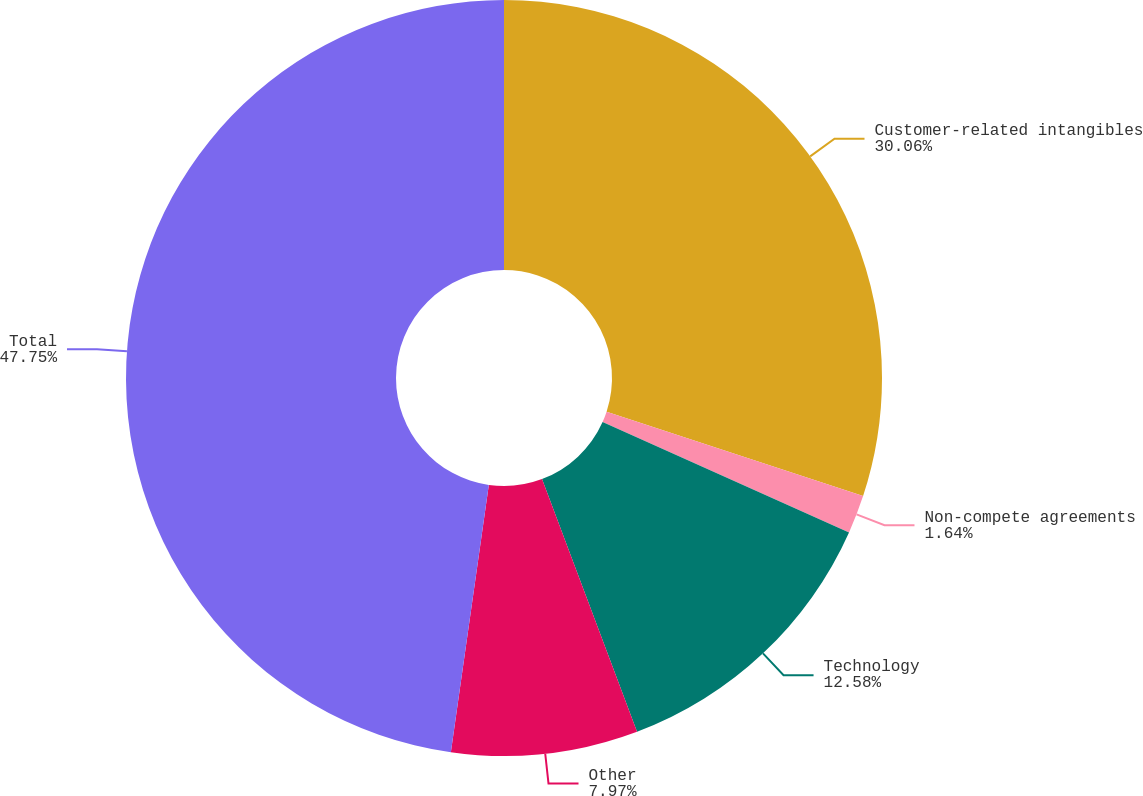Convert chart. <chart><loc_0><loc_0><loc_500><loc_500><pie_chart><fcel>Customer-related intangibles<fcel>Non-compete agreements<fcel>Technology<fcel>Other<fcel>Total<nl><fcel>30.06%<fcel>1.64%<fcel>12.58%<fcel>7.97%<fcel>47.76%<nl></chart> 